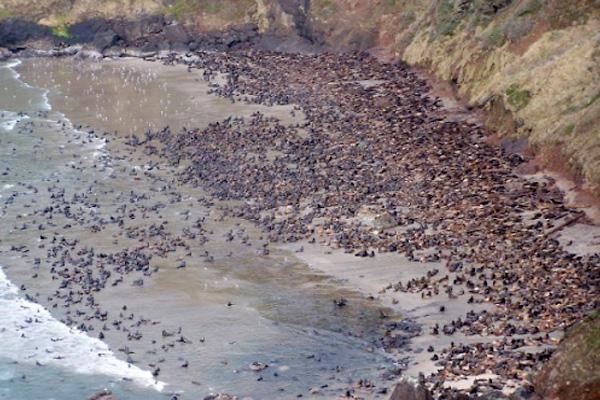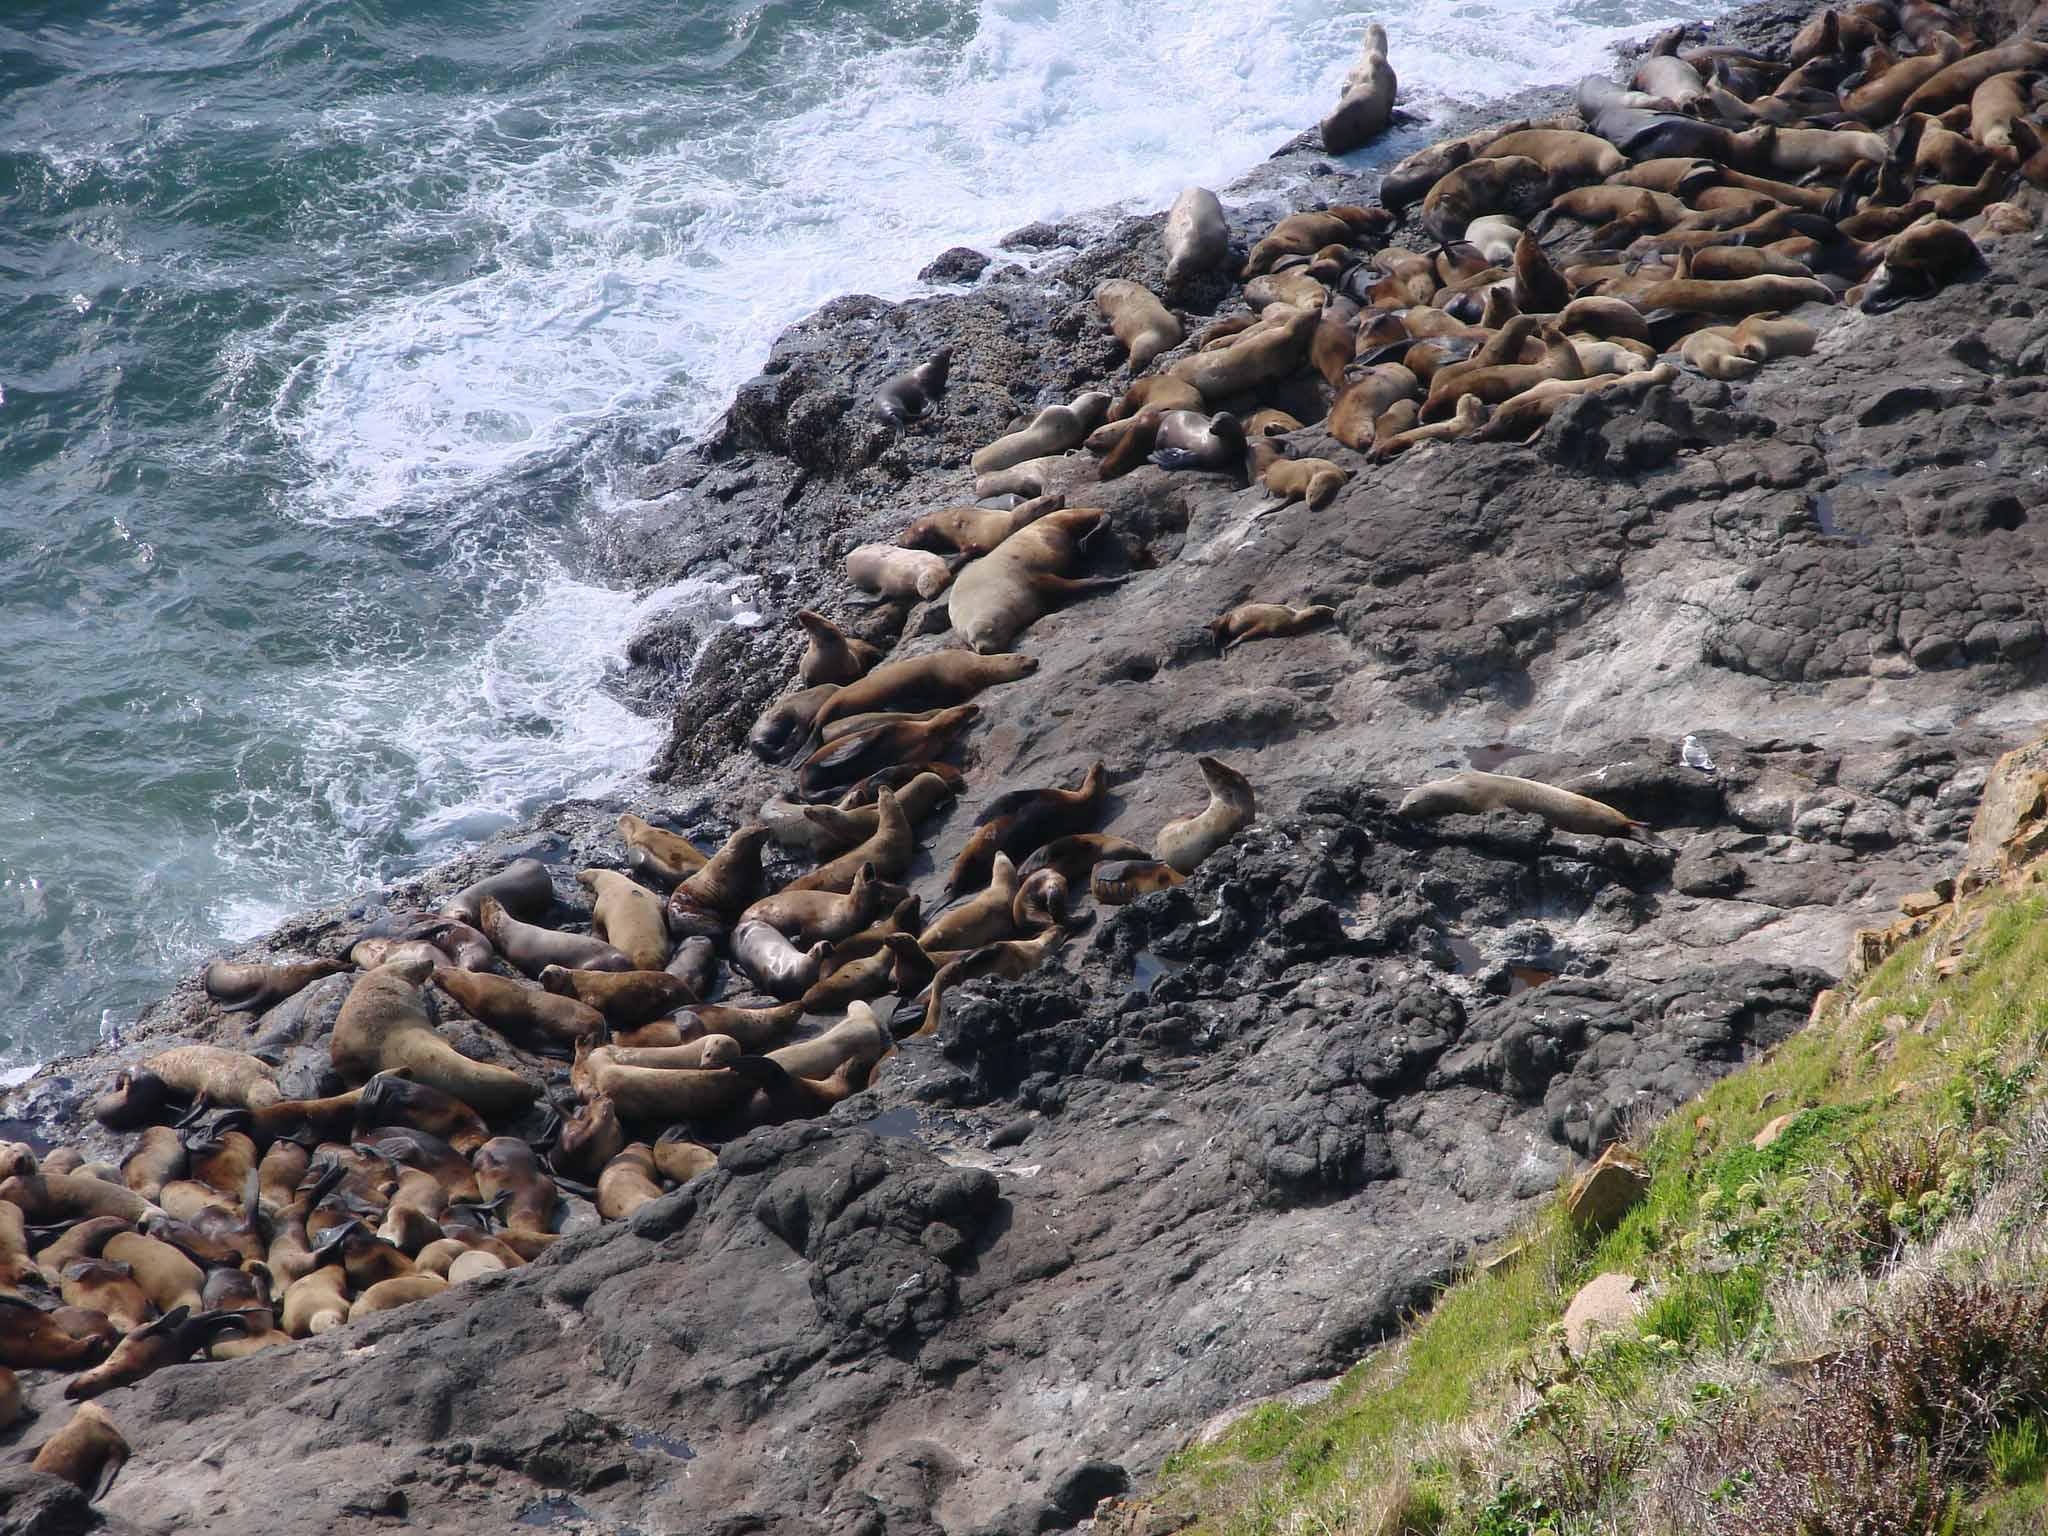The first image is the image on the left, the second image is the image on the right. For the images shown, is this caption "One or more of the photos shows sealions on a rock inside a cave." true? Answer yes or no. No. The first image is the image on the left, the second image is the image on the right. Assess this claim about the two images: "At least one image features a small island full of seals.". Correct or not? Answer yes or no. No. 